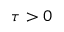Convert formula to latex. <formula><loc_0><loc_0><loc_500><loc_500>\tau > 0</formula> 